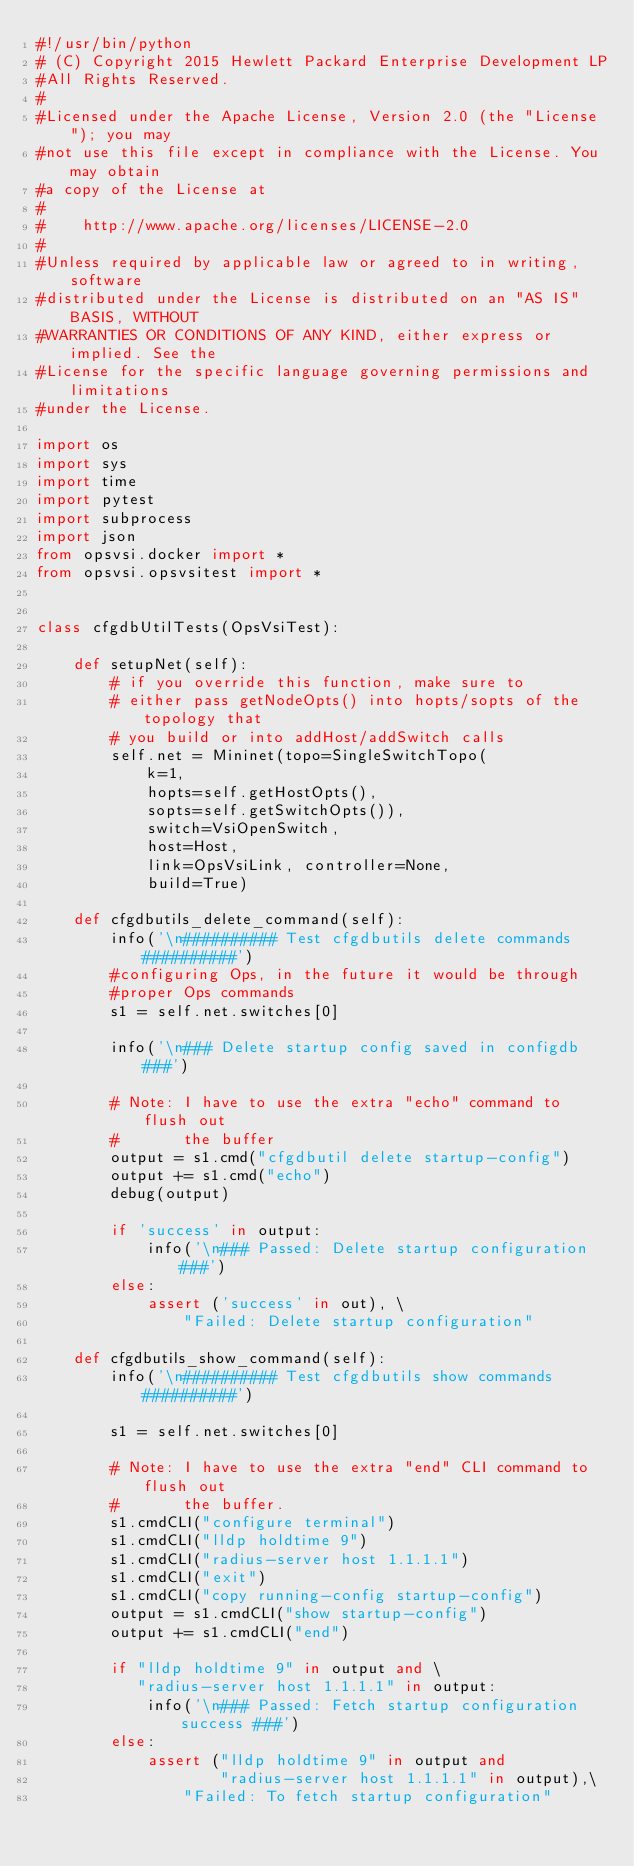Convert code to text. <code><loc_0><loc_0><loc_500><loc_500><_Python_>#!/usr/bin/python
# (C) Copyright 2015 Hewlett Packard Enterprise Development LP
#All Rights Reserved.
#
#Licensed under the Apache License, Version 2.0 (the "License"); you may
#not use this file except in compliance with the License. You may obtain
#a copy of the License at
#
#    http://www.apache.org/licenses/LICENSE-2.0
#
#Unless required by applicable law or agreed to in writing, software
#distributed under the License is distributed on an "AS IS" BASIS, WITHOUT
#WARRANTIES OR CONDITIONS OF ANY KIND, either express or implied. See the
#License for the specific language governing permissions and limitations
#under the License.

import os
import sys
import time
import pytest
import subprocess
import json
from opsvsi.docker import *
from opsvsi.opsvsitest import *


class cfgdbUtilTests(OpsVsiTest):

    def setupNet(self):
        # if you override this function, make sure to
        # either pass getNodeOpts() into hopts/sopts of the topology that
        # you build or into addHost/addSwitch calls
        self.net = Mininet(topo=SingleSwitchTopo(
            k=1,
            hopts=self.getHostOpts(),
            sopts=self.getSwitchOpts()),
            switch=VsiOpenSwitch,
            host=Host,
            link=OpsVsiLink, controller=None,
            build=True)

    def cfgdbutils_delete_command(self):
        info('\n########## Test cfgdbutils delete commands ##########')
        #configuring Ops, in the future it would be through
        #proper Ops commands
        s1 = self.net.switches[0]

        info('\n### Delete startup config saved in configdb ###')

        # Note: I have to use the extra "echo" command to flush out
        #       the buffer
        output = s1.cmd("cfgdbutil delete startup-config")
        output += s1.cmd("echo")
        debug(output)

        if 'success' in output:
            info('\n### Passed: Delete startup configuration ###')
        else:
            assert ('success' in out), \
                "Failed: Delete startup configuration"

    def cfgdbutils_show_command(self):
        info('\n########## Test cfgdbutils show commands ##########')

        s1 = self.net.switches[0]

        # Note: I have to use the extra "end" CLI command to flush out
        #       the buffer.
        s1.cmdCLI("configure terminal")
        s1.cmdCLI("lldp holdtime 9")
        s1.cmdCLI("radius-server host 1.1.1.1")
        s1.cmdCLI("exit")
        s1.cmdCLI("copy running-config startup-config")
        output = s1.cmdCLI("show startup-config")
        output += s1.cmdCLI("end")

        if "lldp holdtime 9" in output and \
           "radius-server host 1.1.1.1" in output:
            info('\n### Passed: Fetch startup configuration success ###')
        else:
            assert ("lldp holdtime 9" in output and
                    "radius-server host 1.1.1.1" in output),\
                "Failed: To fetch startup configuration"
</code> 